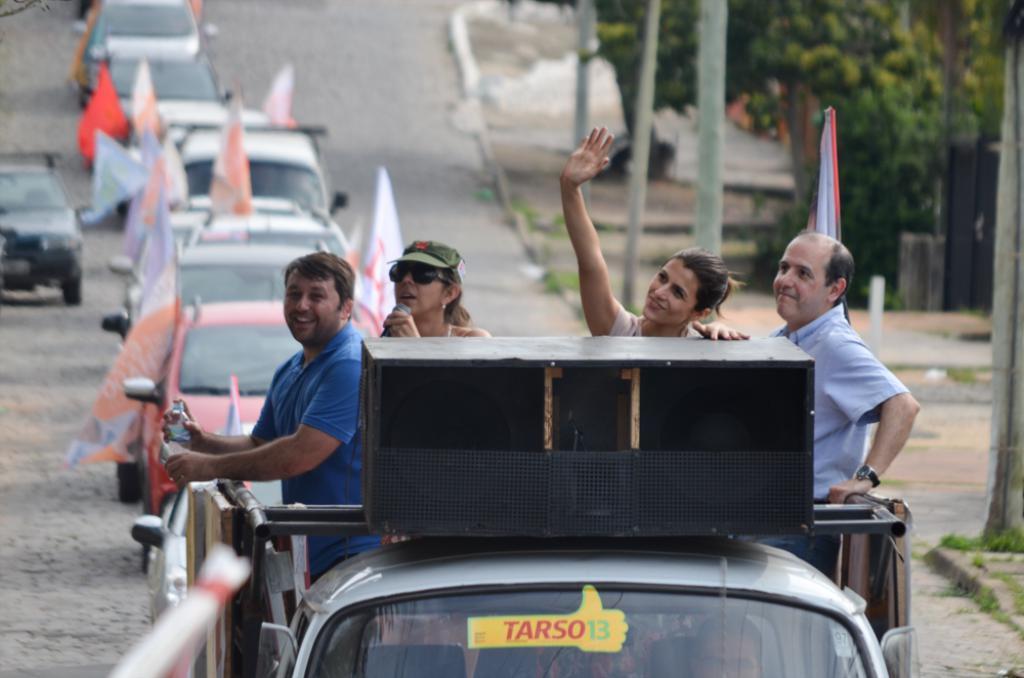Could you give a brief overview of what you see in this image? In this image, we can see few people are riding a vehicle. Here a woman is holding a microphone and three persons are smiling. Background there is a blur view. Here we can see few vehicles on the road. On the right side of the image, we can see poles, grass, plants and road. Here there are few flags. 